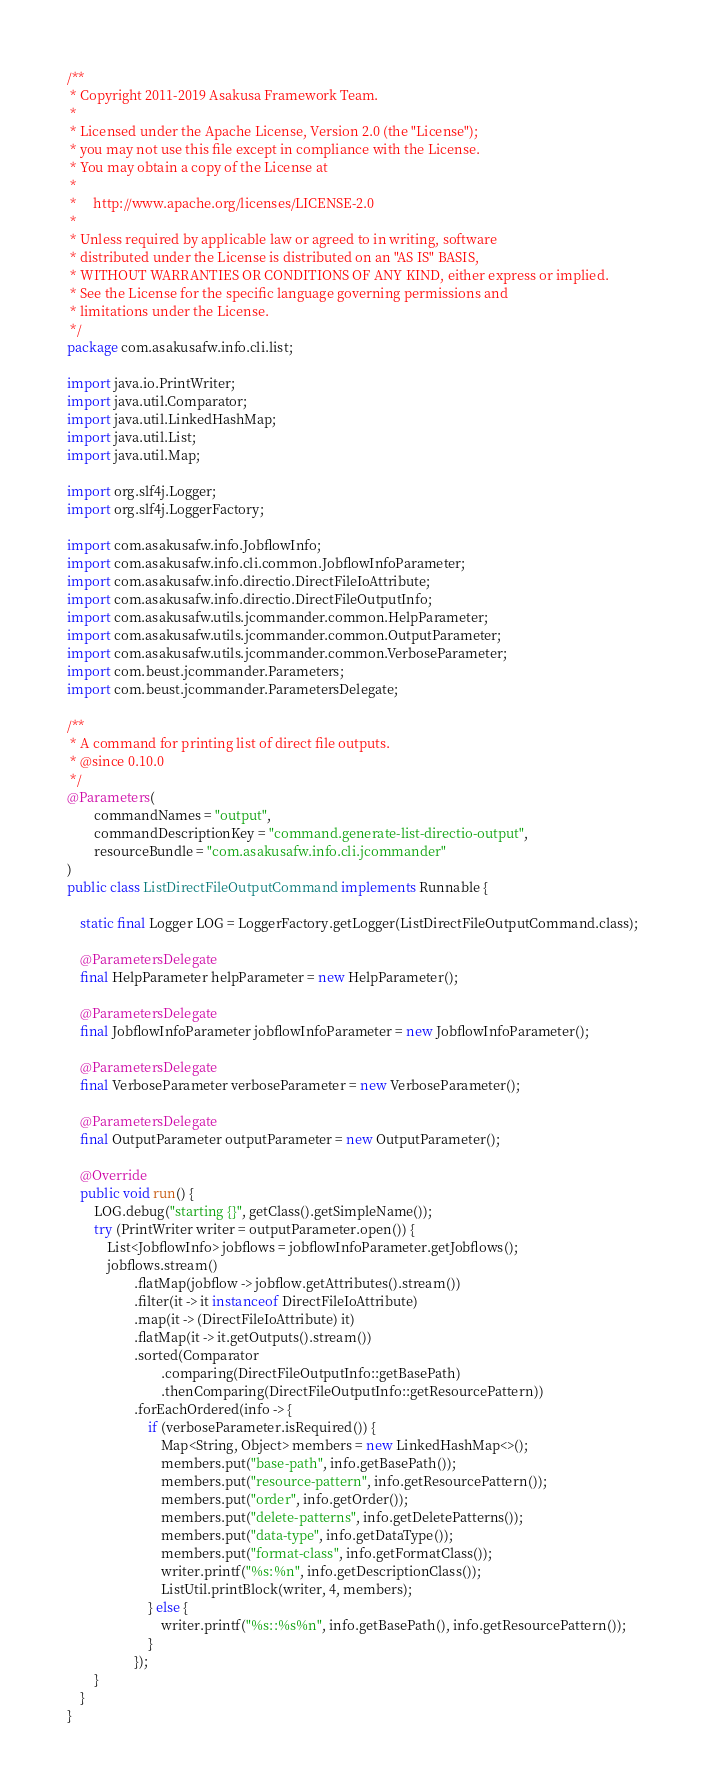Convert code to text. <code><loc_0><loc_0><loc_500><loc_500><_Java_>/**
 * Copyright 2011-2019 Asakusa Framework Team.
 *
 * Licensed under the Apache License, Version 2.0 (the "License");
 * you may not use this file except in compliance with the License.
 * You may obtain a copy of the License at
 *
 *     http://www.apache.org/licenses/LICENSE-2.0
 *
 * Unless required by applicable law or agreed to in writing, software
 * distributed under the License is distributed on an "AS IS" BASIS,
 * WITHOUT WARRANTIES OR CONDITIONS OF ANY KIND, either express or implied.
 * See the License for the specific language governing permissions and
 * limitations under the License.
 */
package com.asakusafw.info.cli.list;

import java.io.PrintWriter;
import java.util.Comparator;
import java.util.LinkedHashMap;
import java.util.List;
import java.util.Map;

import org.slf4j.Logger;
import org.slf4j.LoggerFactory;

import com.asakusafw.info.JobflowInfo;
import com.asakusafw.info.cli.common.JobflowInfoParameter;
import com.asakusafw.info.directio.DirectFileIoAttribute;
import com.asakusafw.info.directio.DirectFileOutputInfo;
import com.asakusafw.utils.jcommander.common.HelpParameter;
import com.asakusafw.utils.jcommander.common.OutputParameter;
import com.asakusafw.utils.jcommander.common.VerboseParameter;
import com.beust.jcommander.Parameters;
import com.beust.jcommander.ParametersDelegate;

/**
 * A command for printing list of direct file outputs.
 * @since 0.10.0
 */
@Parameters(
        commandNames = "output",
        commandDescriptionKey = "command.generate-list-directio-output",
        resourceBundle = "com.asakusafw.info.cli.jcommander"
)
public class ListDirectFileOutputCommand implements Runnable {

    static final Logger LOG = LoggerFactory.getLogger(ListDirectFileOutputCommand.class);

    @ParametersDelegate
    final HelpParameter helpParameter = new HelpParameter();

    @ParametersDelegate
    final JobflowInfoParameter jobflowInfoParameter = new JobflowInfoParameter();

    @ParametersDelegate
    final VerboseParameter verboseParameter = new VerboseParameter();

    @ParametersDelegate
    final OutputParameter outputParameter = new OutputParameter();

    @Override
    public void run() {
        LOG.debug("starting {}", getClass().getSimpleName());
        try (PrintWriter writer = outputParameter.open()) {
            List<JobflowInfo> jobflows = jobflowInfoParameter.getJobflows();
            jobflows.stream()
                    .flatMap(jobflow -> jobflow.getAttributes().stream())
                    .filter(it -> it instanceof DirectFileIoAttribute)
                    .map(it -> (DirectFileIoAttribute) it)
                    .flatMap(it -> it.getOutputs().stream())
                    .sorted(Comparator
                            .comparing(DirectFileOutputInfo::getBasePath)
                            .thenComparing(DirectFileOutputInfo::getResourcePattern))
                    .forEachOrdered(info -> {
                        if (verboseParameter.isRequired()) {
                            Map<String, Object> members = new LinkedHashMap<>();
                            members.put("base-path", info.getBasePath());
                            members.put("resource-pattern", info.getResourcePattern());
                            members.put("order", info.getOrder());
                            members.put("delete-patterns", info.getDeletePatterns());
                            members.put("data-type", info.getDataType());
                            members.put("format-class", info.getFormatClass());
                            writer.printf("%s:%n", info.getDescriptionClass());
                            ListUtil.printBlock(writer, 4, members);
                        } else {
                            writer.printf("%s::%s%n", info.getBasePath(), info.getResourcePattern());
                        }
                    });
        }
    }
}
</code> 